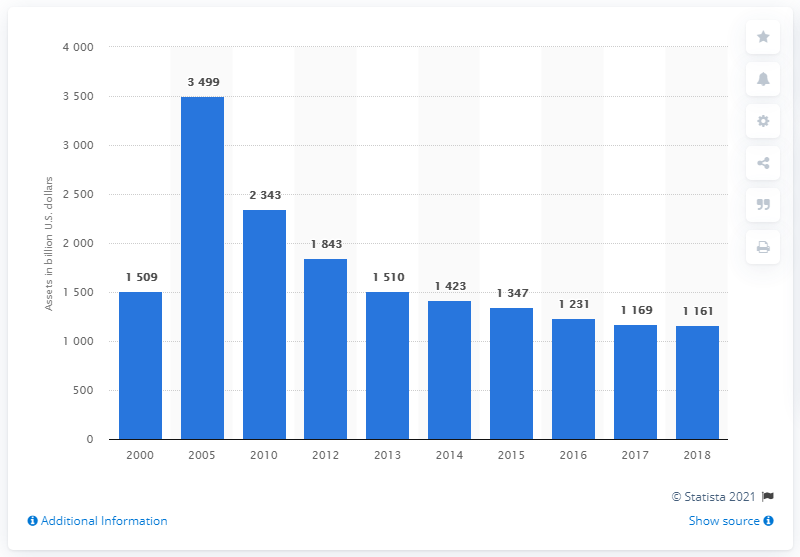Give some essential details in this illustration. The financial assets of asset-backed securities issuers in the United States in 2018 was 1161. 